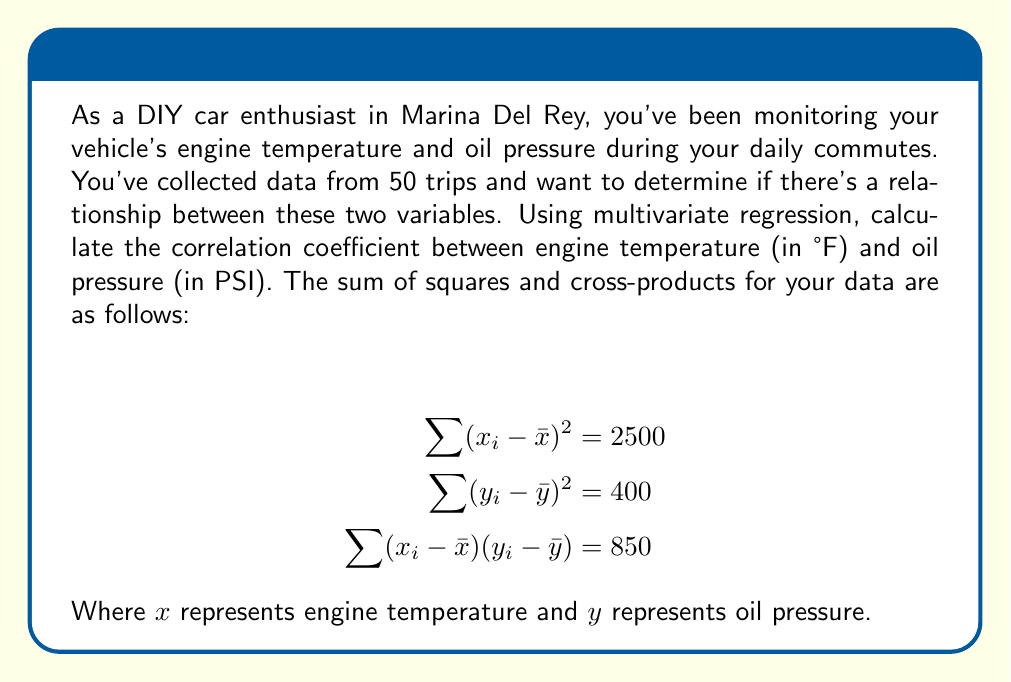Solve this math problem. To calculate the correlation coefficient between engine temperature and oil pressure using multivariate regression, we'll use the Pearson correlation coefficient formula:

$$r = \frac{\sum (x_i - \bar{x})(y_i - \bar{y})}{\sqrt{\sum (x_i - \bar{x})^2 \sum (y_i - \bar{y})^2}}$$

Given:
$$\sum (x_i - \bar{x})^2 = 2500$$
$$\sum (y_i - \bar{y})^2 = 400$$
$$\sum (x_i - \bar{x})(y_i - \bar{y}) = 850$$

Step 1: Substitute the given values into the formula:

$$r = \frac{850}{\sqrt{2500 \times 400}}$$

Step 2: Simplify the denominator:
$$r = \frac{850}{\sqrt{1,000,000}}$$

Step 3: Calculate the square root in the denominator:
$$r = \frac{850}{1000}$$

Step 4: Simplify the fraction:
$$r = 0.85$$

The correlation coefficient ranges from -1 to 1, where:
- 1 indicates a perfect positive correlation
- 0 indicates no correlation
- -1 indicates a perfect negative correlation

In this case, the correlation coefficient of 0.85 indicates a strong positive correlation between engine temperature and oil pressure.
Answer: The correlation coefficient between engine temperature and oil pressure is 0.85, indicating a strong positive correlation. 